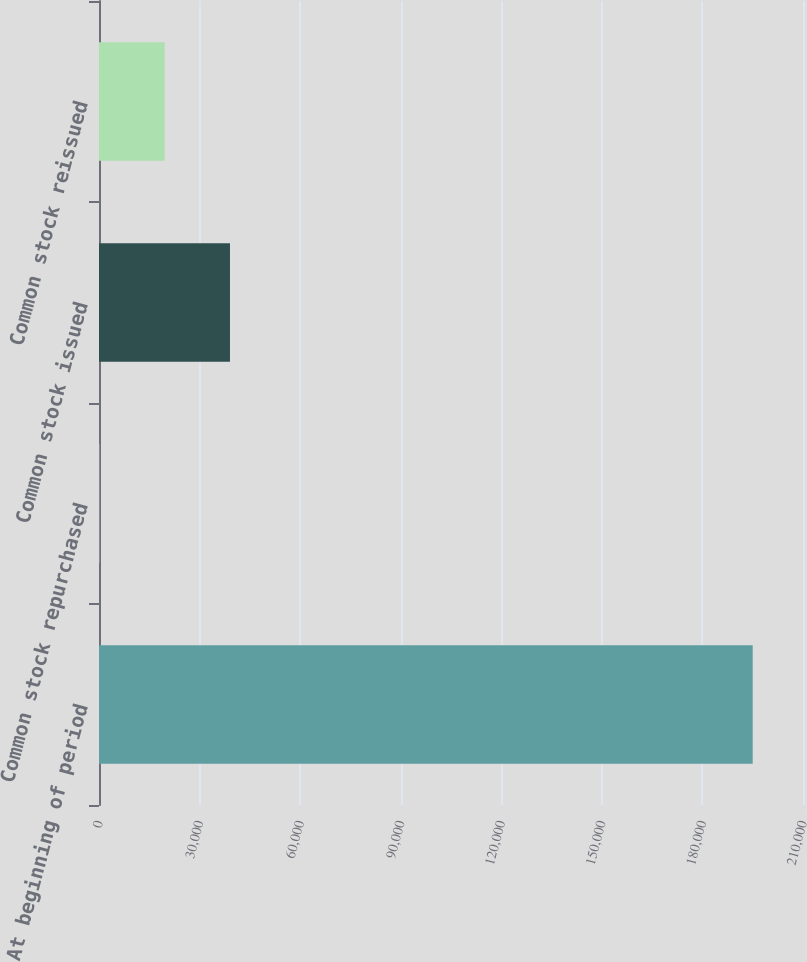<chart> <loc_0><loc_0><loc_500><loc_500><bar_chart><fcel>At beginning of period<fcel>Common stock repurchased<fcel>Common stock issued<fcel>Common stock reissued<nl><fcel>194997<fcel>88<fcel>39069.8<fcel>19578.9<nl></chart> 